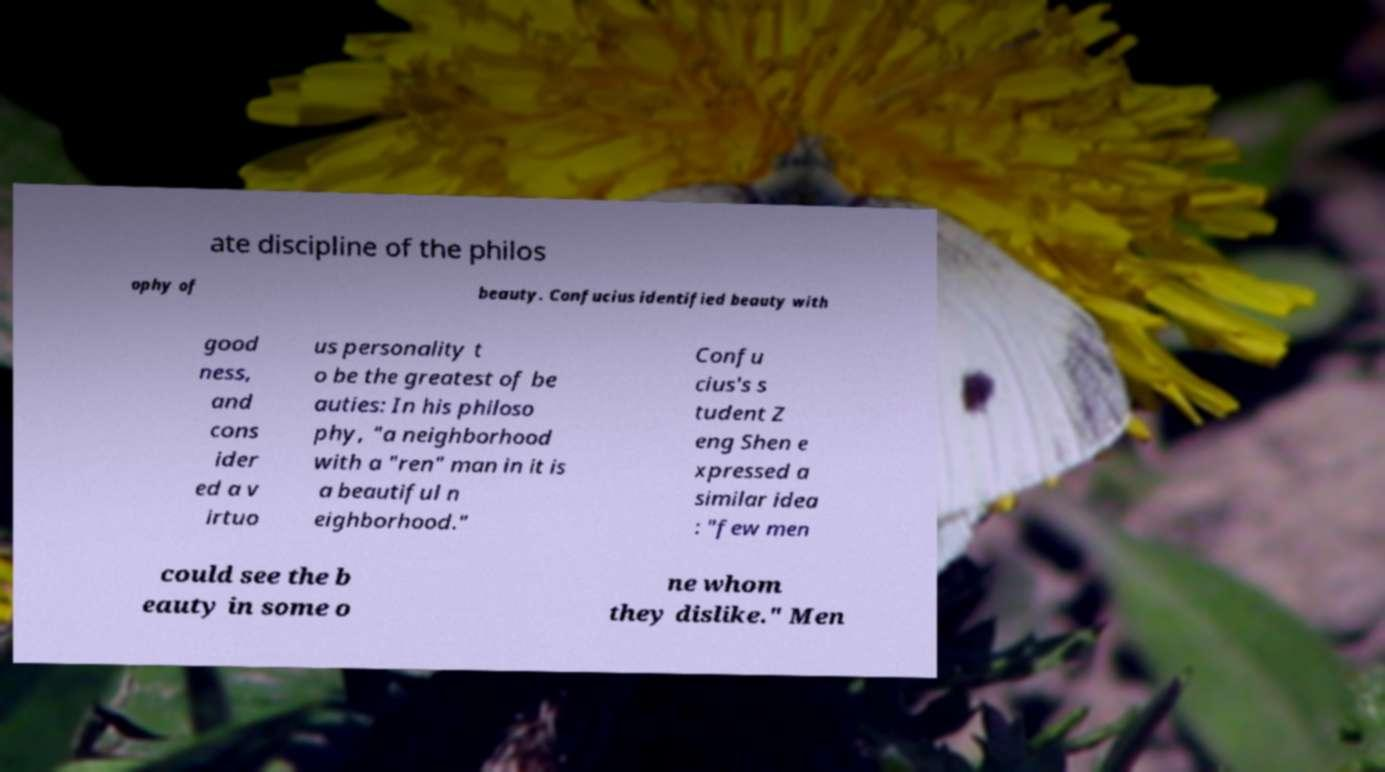What messages or text are displayed in this image? I need them in a readable, typed format. ate discipline of the philos ophy of beauty. Confucius identified beauty with good ness, and cons ider ed a v irtuo us personality t o be the greatest of be auties: In his philoso phy, "a neighborhood with a "ren" man in it is a beautiful n eighborhood." Confu cius's s tudent Z eng Shen e xpressed a similar idea : "few men could see the b eauty in some o ne whom they dislike." Men 